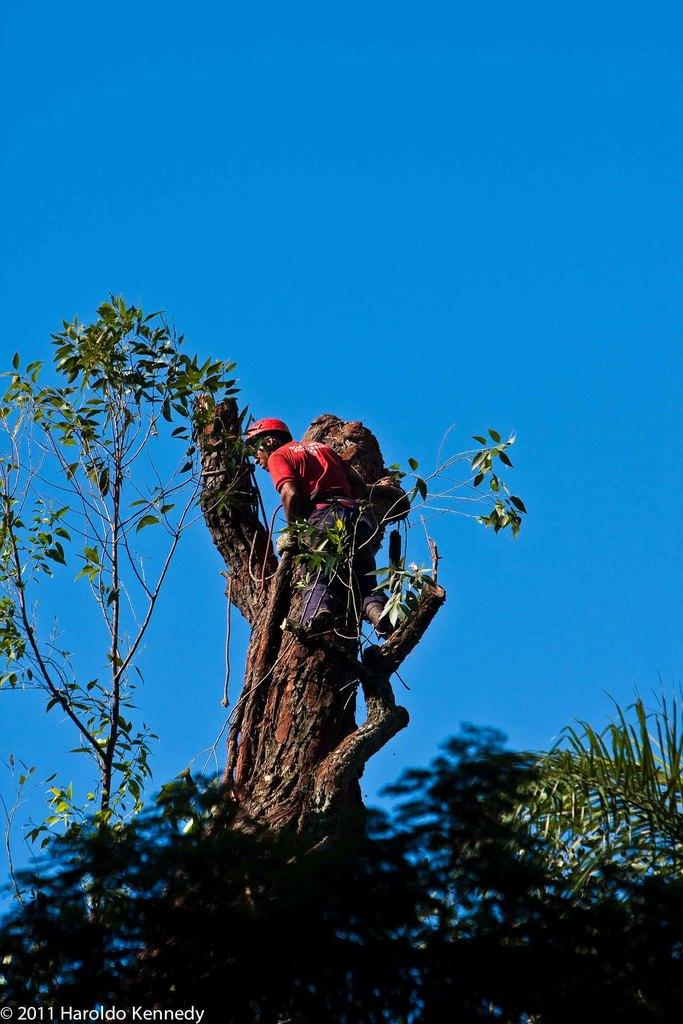Who or what is present in the image? There is a person in the image. What is the person wearing? The person is wearing a helmet. What is the person holding in the image? The person is holding the bark of a tree. What type of natural elements can be seen in the image? There are plants visible in the image. What part of the environment is visible in the image? The sky is visible in the image. What type of soda is being poured into the person's helmet in the image? There is no soda present in the image, nor is any liquid being poured into the person's helmet. 